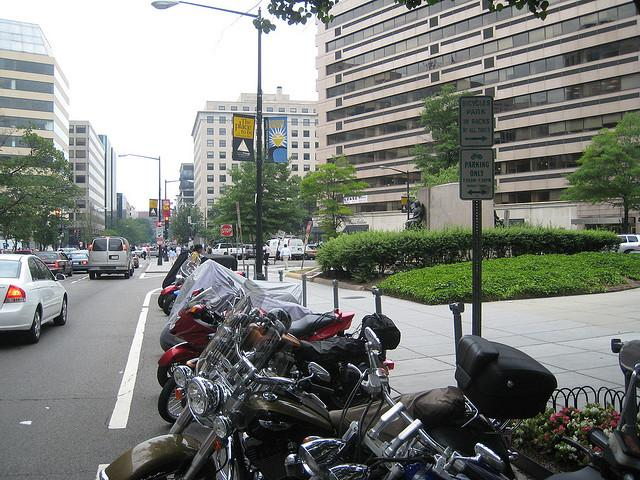What types of people use this part of the street the most? bikers 